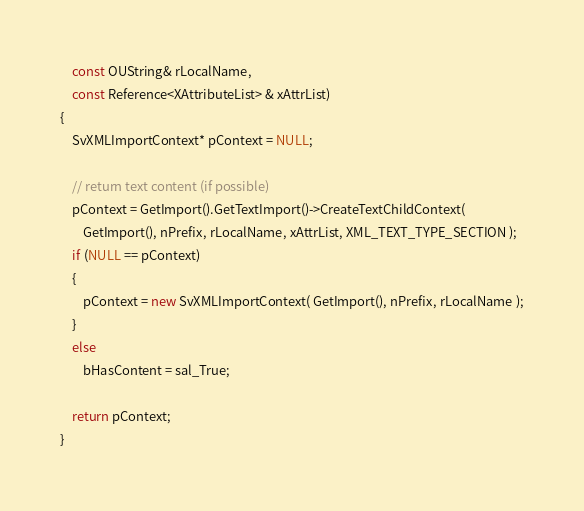<code> <loc_0><loc_0><loc_500><loc_500><_C++_>	const OUString& rLocalName,
	const Reference<XAttributeList> & xAttrList)
{
	SvXMLImportContext* pContext = NULL;

	// return text content (if possible)
	pContext = GetImport().GetTextImport()->CreateTextChildContext(
		GetImport(), nPrefix, rLocalName, xAttrList, XML_TEXT_TYPE_SECTION );
	if (NULL == pContext)
	{
		pContext = new SvXMLImportContext( GetImport(), nPrefix, rLocalName );
	}
    else
        bHasContent = sal_True;

	return pContext;
}
</code> 